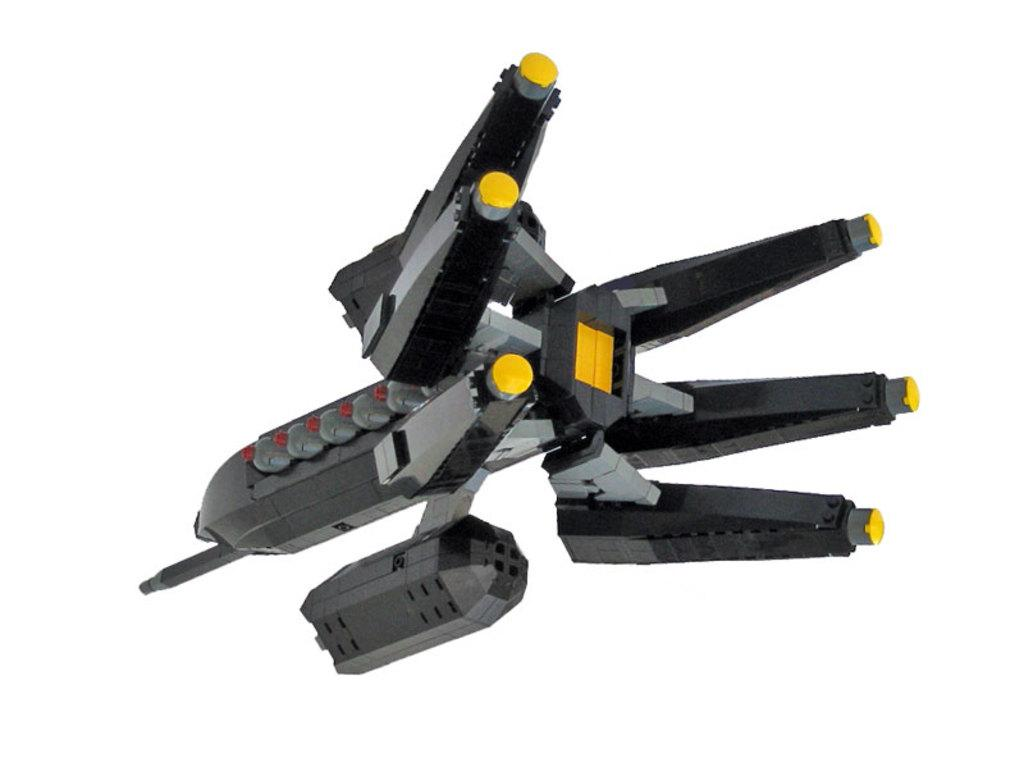What object can be seen in the image? There is a toy in the image. What is the color of the surface the toy is placed on? The toy is on a white surface. What is the name of the bear that the toy is thinking about in the image? There are no bears present in the image, and the toy is not shown to be thinking about anything. 